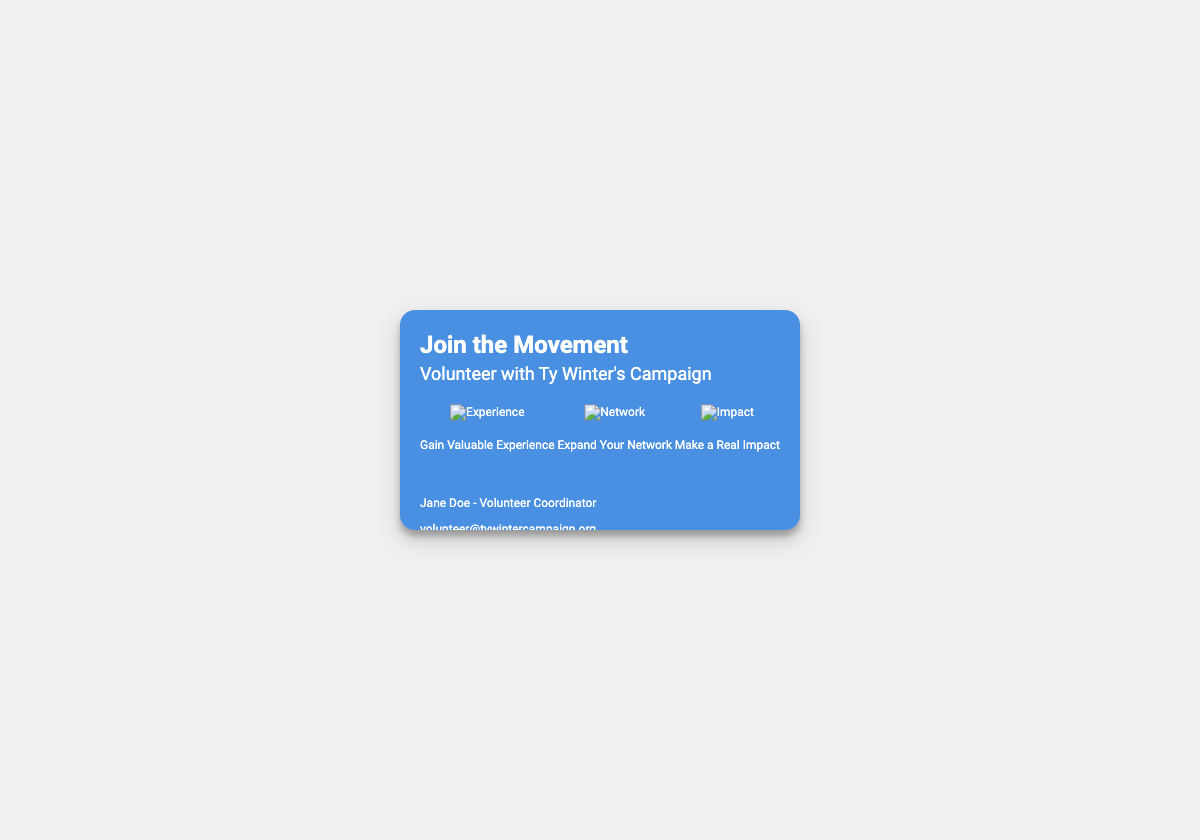What is the name of the volunteer coordinator? The volunteer coordinator's name is mentioned in the contact section of the document.
Answer: Jane Doe What is the campaign's email address? The email address for contacting the campaign is provided in the contact section.
Answer: volunteer@tywintercampaign.org When is the Phone Banking opportunity? The date for the Phone Banking event is listed under upcoming opportunities.
Answer: October 15, 2023 What kind of experience can volunteers gain by joining the campaign? The benefits of volunteering include gaining experience, which is stated on the front of the card.
Answer: Valuable Experience What is the address of the campaign office? The address is detailed on the back of the card, referencing the campaign's location.
Answer: 123 Democracy Lane, Suite 456, Winning City, WA 98001 How many upcoming opportunities are listed on the card? The card lists multiple upcoming opportunities for volunteering, specifically shown on the back.
Answer: 3 What is one benefit of volunteering according to the card? One of the benefits is highlighted in the benefits section, showing what volunteers can gain.
Answer: Make a Real Impact What type of activity is scheduled for October 20, 2023? The activity scheduled on this date is mentioned under upcoming opportunities.
Answer: Door-to-Door Canvassing How many icons are displayed in the benefits section? The benefits section contains icons representing different advantages of volunteering.
Answer: 3 